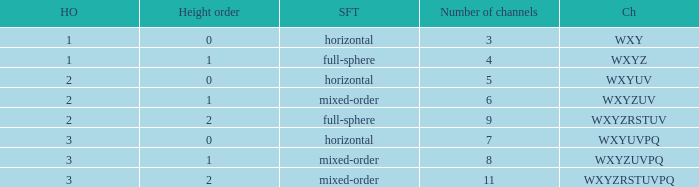For the channel sequence wxyzuv, how many channels are there? 6.0. 